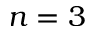Convert formula to latex. <formula><loc_0><loc_0><loc_500><loc_500>n = 3</formula> 